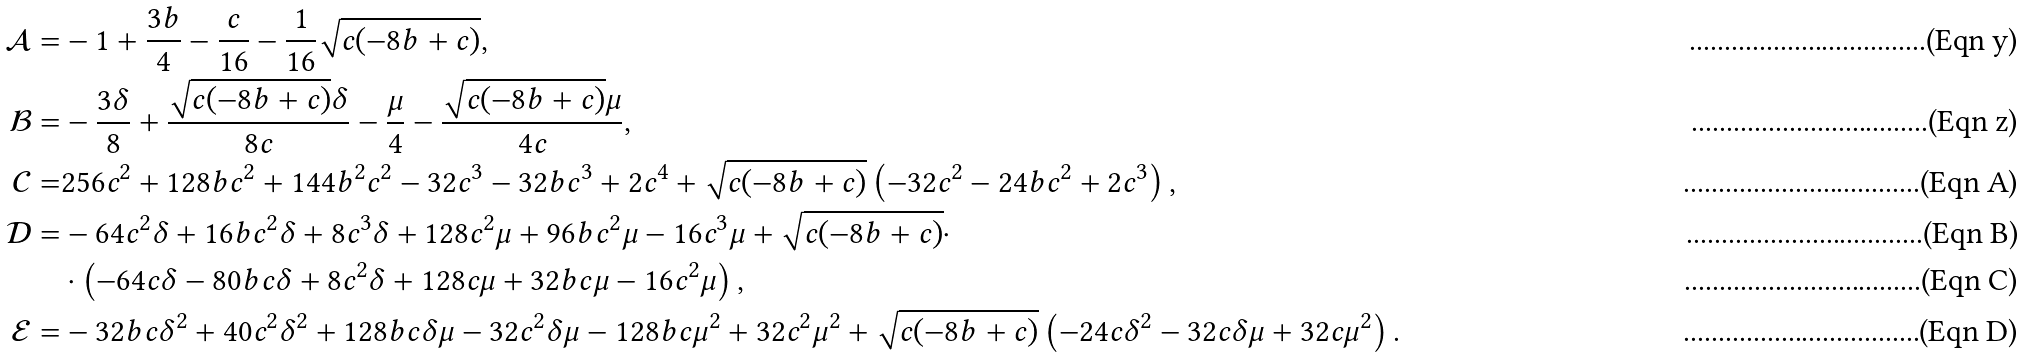Convert formula to latex. <formula><loc_0><loc_0><loc_500><loc_500>\mathcal { A } = & - 1 + \frac { 3 b } { 4 } - \frac { c } { 1 6 } - \frac { 1 } { 1 6 } \sqrt { c ( - 8 b + c ) } , \\ \mathcal { B } = & - \frac { 3 \delta } { 8 } + \frac { \sqrt { c ( - 8 b + c ) } \delta } { 8 c } - \frac { \mu } { 4 } - \frac { \sqrt { c ( - 8 b + c ) } \mu } { 4 c } , \\ \mathcal { C } = & 2 5 6 c ^ { 2 } + 1 2 8 b c ^ { 2 } + 1 4 4 b ^ { 2 } c ^ { 2 } - 3 2 c ^ { 3 } - 3 2 b c ^ { 3 } + 2 c ^ { 4 } + \sqrt { c ( - 8 b + c ) } \left ( - 3 2 c ^ { 2 } - 2 4 b c ^ { 2 } + 2 c ^ { 3 } \right ) , \\ \mathcal { D } = & - 6 4 c ^ { 2 } \delta + 1 6 b c ^ { 2 } \delta + 8 c ^ { 3 } \delta + 1 2 8 c ^ { 2 } \mu + 9 6 b c ^ { 2 } \mu - 1 6 c ^ { 3 } \mu + \sqrt { c ( - 8 b + c ) } \cdot \\ & \cdot \left ( - 6 4 c \delta - 8 0 b c \delta + 8 c ^ { 2 } \delta + 1 2 8 c \mu + 3 2 b c \mu - 1 6 c ^ { 2 } \mu \right ) , \\ \mathcal { E } = & - 3 2 b c \delta ^ { 2 } + 4 0 c ^ { 2 } \delta ^ { 2 } + 1 2 8 b c \delta \mu - 3 2 c ^ { 2 } \delta \mu - 1 2 8 b c \mu ^ { 2 } + 3 2 c ^ { 2 } \mu ^ { 2 } + \sqrt { c ( - 8 b + c ) } \left ( - 2 4 c \delta ^ { 2 } - 3 2 c \delta \mu + 3 2 c \mu ^ { 2 } \right ) .</formula> 